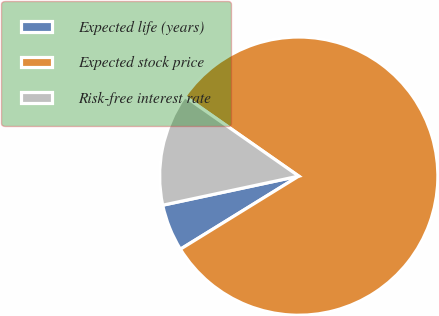<chart> <loc_0><loc_0><loc_500><loc_500><pie_chart><fcel>Expected life (years)<fcel>Expected stock price<fcel>Risk-free interest rate<nl><fcel>5.45%<fcel>81.49%<fcel>13.06%<nl></chart> 